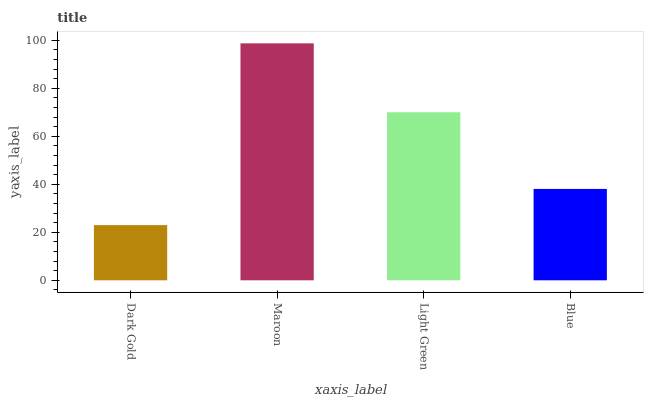Is Dark Gold the minimum?
Answer yes or no. Yes. Is Maroon the maximum?
Answer yes or no. Yes. Is Light Green the minimum?
Answer yes or no. No. Is Light Green the maximum?
Answer yes or no. No. Is Maroon greater than Light Green?
Answer yes or no. Yes. Is Light Green less than Maroon?
Answer yes or no. Yes. Is Light Green greater than Maroon?
Answer yes or no. No. Is Maroon less than Light Green?
Answer yes or no. No. Is Light Green the high median?
Answer yes or no. Yes. Is Blue the low median?
Answer yes or no. Yes. Is Dark Gold the high median?
Answer yes or no. No. Is Light Green the low median?
Answer yes or no. No. 